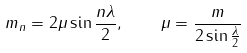<formula> <loc_0><loc_0><loc_500><loc_500>m _ { n } = 2 \mu \sin \frac { n \lambda } { 2 } , \quad \mu = \frac { m } { 2 \sin \frac { \lambda } { 2 } }</formula> 